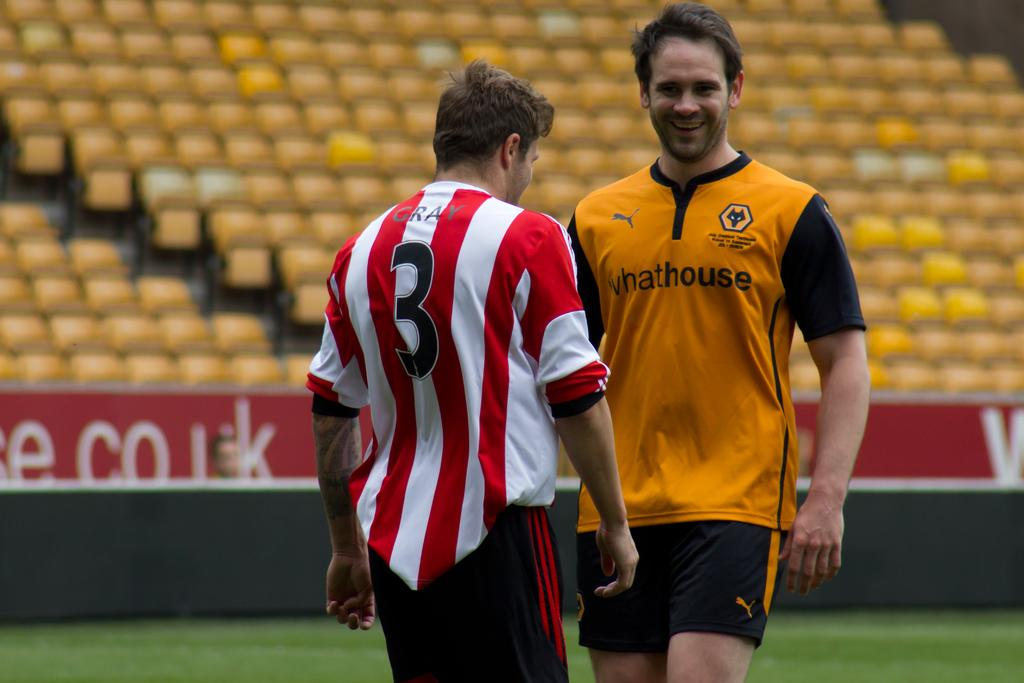<image>
Offer a succinct explanation of the picture presented. Player number 3 is talking to a man in a yellow jersey. 